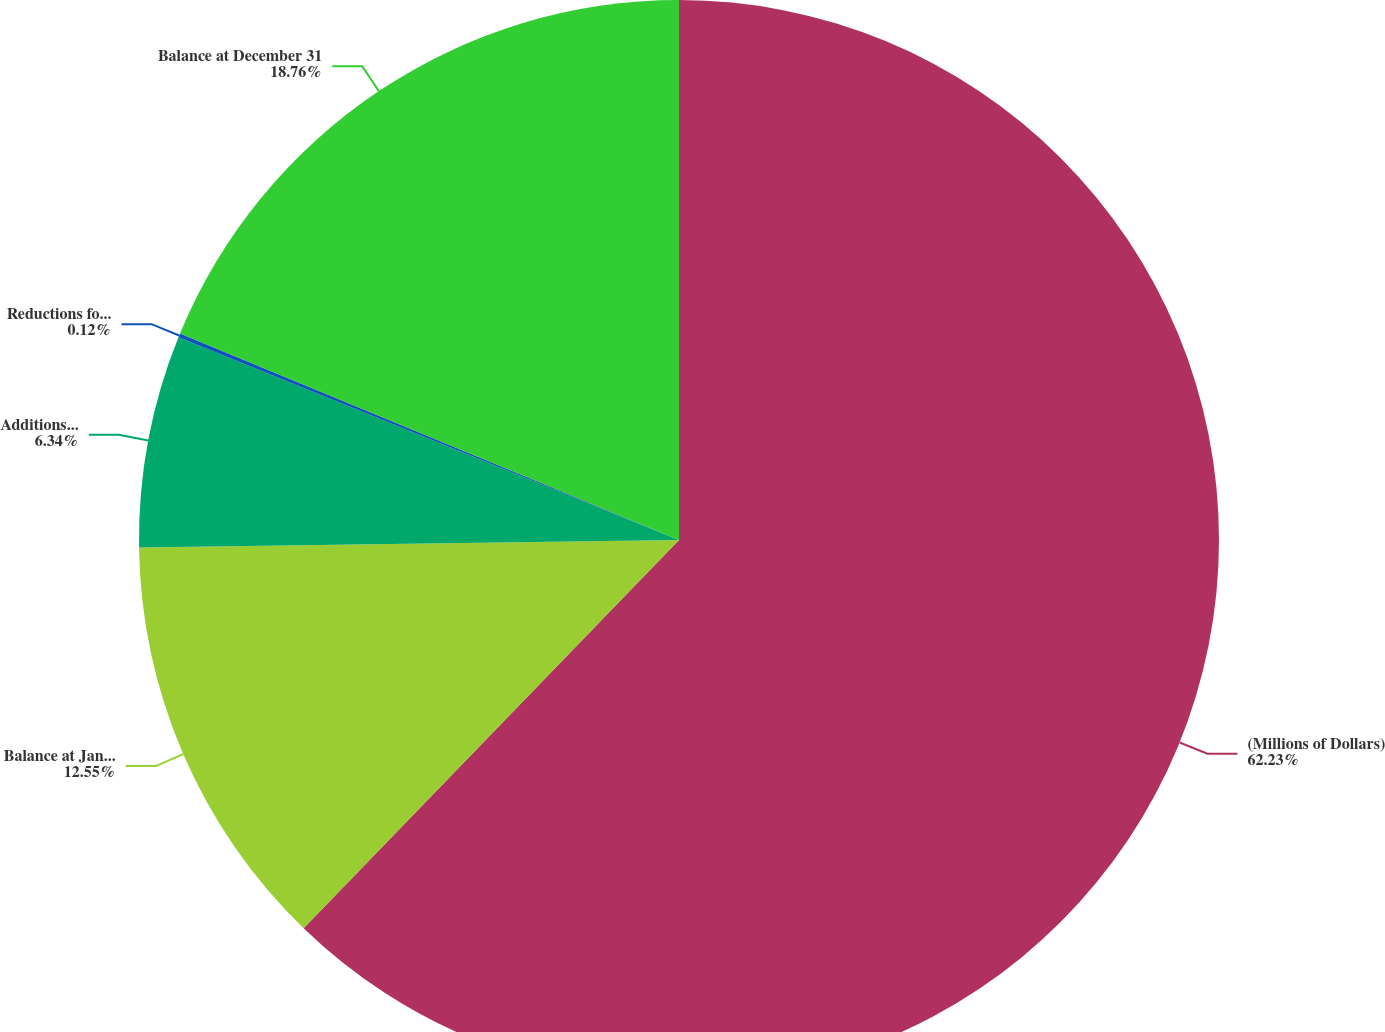Convert chart to OTSL. <chart><loc_0><loc_0><loc_500><loc_500><pie_chart><fcel>(Millions of Dollars)<fcel>Balance at January 1<fcel>Additions based on tax<fcel>Reductions for tax positions<fcel>Balance at December 31<nl><fcel>62.24%<fcel>12.55%<fcel>6.34%<fcel>0.12%<fcel>18.76%<nl></chart> 